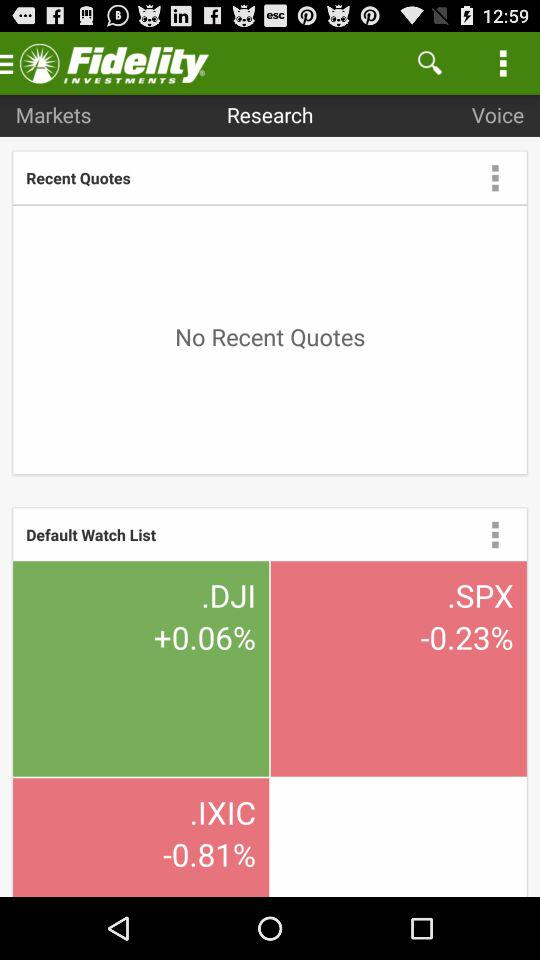What is the percentage change in.IXIC? The percentage change in.IXIC is -0.81. 